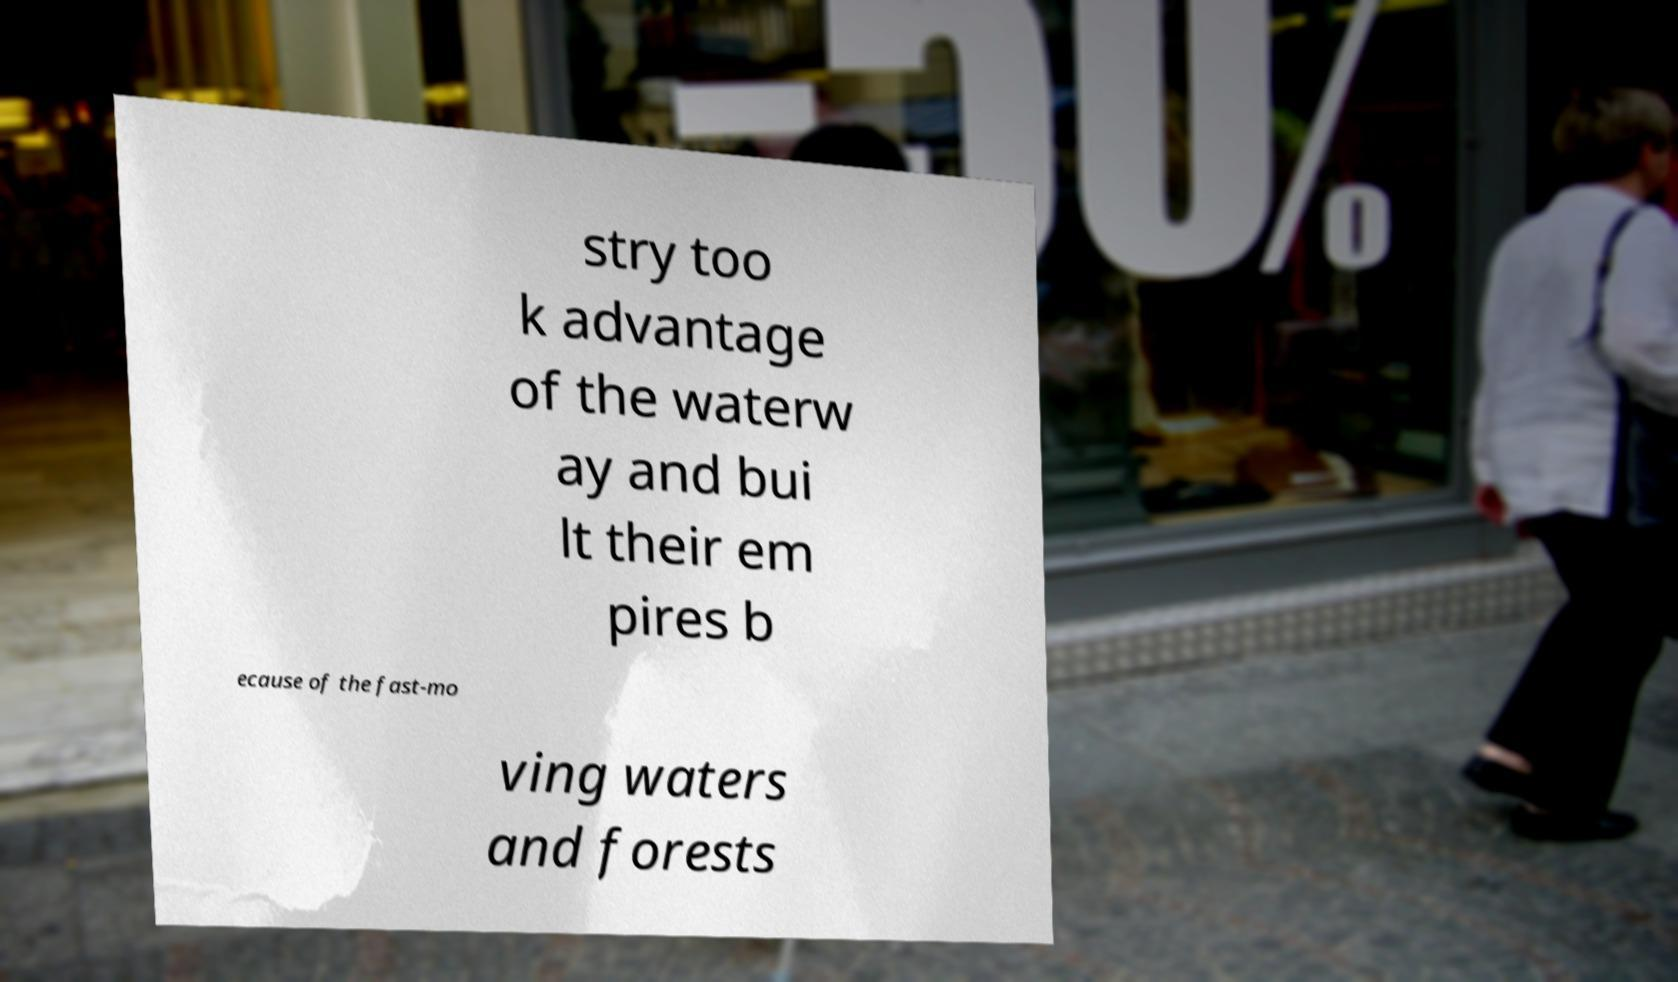Please identify and transcribe the text found in this image. stry too k advantage of the waterw ay and bui lt their em pires b ecause of the fast-mo ving waters and forests 